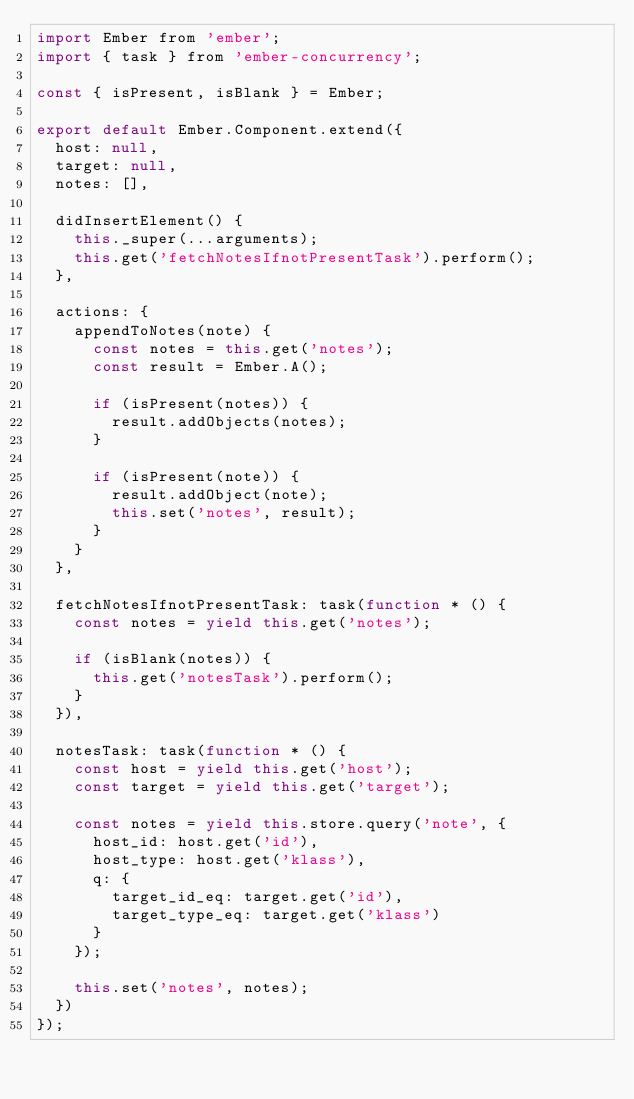Convert code to text. <code><loc_0><loc_0><loc_500><loc_500><_JavaScript_>import Ember from 'ember';
import { task } from 'ember-concurrency';

const { isPresent, isBlank } = Ember;

export default Ember.Component.extend({
  host: null,
  target: null,
  notes: [],

  didInsertElement() {
    this._super(...arguments);
    this.get('fetchNotesIfnotPresentTask').perform();
  },

  actions: {
    appendToNotes(note) {
      const notes = this.get('notes');
      const result = Ember.A();

      if (isPresent(notes)) {
        result.addObjects(notes);
      }

      if (isPresent(note)) {
        result.addObject(note);
        this.set('notes', result);
      }
    }
  },

  fetchNotesIfnotPresentTask: task(function * () {
    const notes = yield this.get('notes');

    if (isBlank(notes)) {
      this.get('notesTask').perform();
    }
  }),

  notesTask: task(function * () {
    const host = yield this.get('host');
    const target = yield this.get('target');

    const notes = yield this.store.query('note', {
      host_id: host.get('id'),
      host_type: host.get('klass'),
      q: {
        target_id_eq: target.get('id'),
        target_type_eq: target.get('klass')
      }
    });

    this.set('notes', notes);
  })
});
</code> 